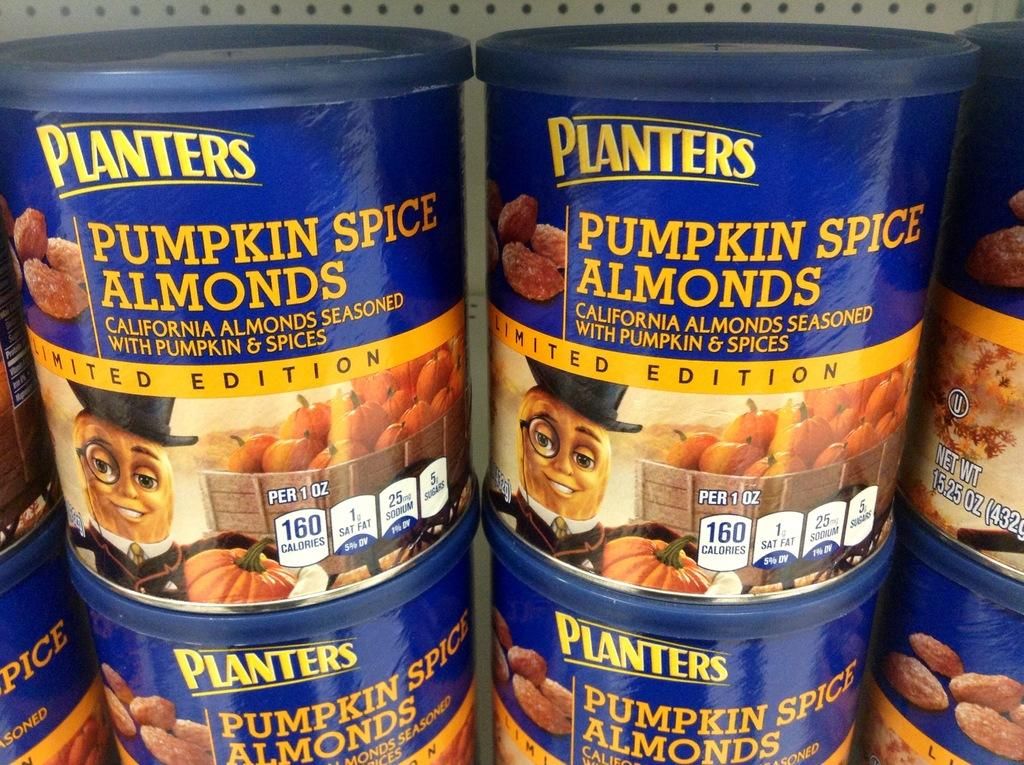What objects are present in the image? There are boxes in the image. What color are the boxes? The boxes are blue in color. What is the surface on which the boxes are placed? The boxes are on white rocks. What is depicted on the boxes? There are pictures of fruits on the boxes. What information is printed on the boxes? There are words printed on the boxes. How many fingers can be seen on the bike in the image? There is no bike present in the image, and therefore no fingers can be seen on a bike. 